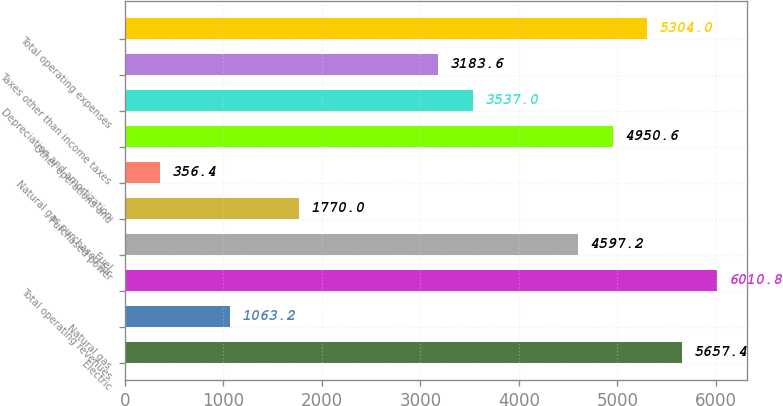Convert chart. <chart><loc_0><loc_0><loc_500><loc_500><bar_chart><fcel>Electric<fcel>Natural gas<fcel>Total operating revenues<fcel>Fuel<fcel>Purchased power<fcel>Natural gas purchased for<fcel>Other operations and<fcel>Depreciation and amortization<fcel>Taxes other than income taxes<fcel>Total operating expenses<nl><fcel>5657.4<fcel>1063.2<fcel>6010.8<fcel>4597.2<fcel>1770<fcel>356.4<fcel>4950.6<fcel>3537<fcel>3183.6<fcel>5304<nl></chart> 